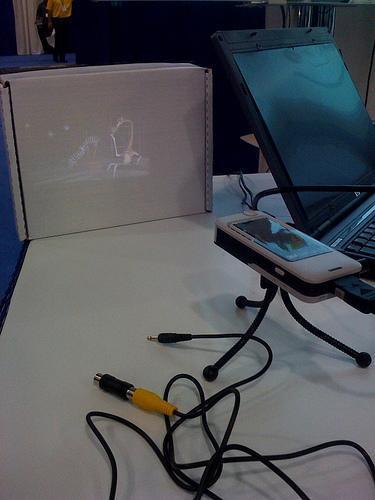How many pillows are on the bed?
Give a very brief answer. 0. How many cell phones can you see?
Give a very brief answer. 1. 